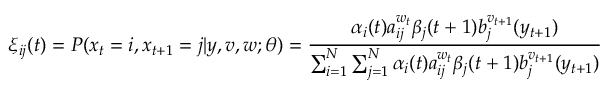Convert formula to latex. <formula><loc_0><loc_0><loc_500><loc_500>\xi _ { i j } ( t ) = P ( x _ { t } = i , x _ { t + 1 } = j | y , v , w ; \theta ) = { \frac { \alpha _ { i } ( t ) a _ { i j } ^ { w _ { t } } \beta _ { j } ( t + 1 ) b _ { j } ^ { v _ { t + 1 } } ( y _ { t + 1 } ) } { \sum _ { i = 1 } ^ { N } \sum _ { j = 1 } ^ { N } \alpha _ { i } ( t ) a _ { i j } ^ { w _ { t } } \beta _ { j } ( t + 1 ) b _ { j } ^ { v _ { t + 1 } } ( y _ { t + 1 } ) } }</formula> 